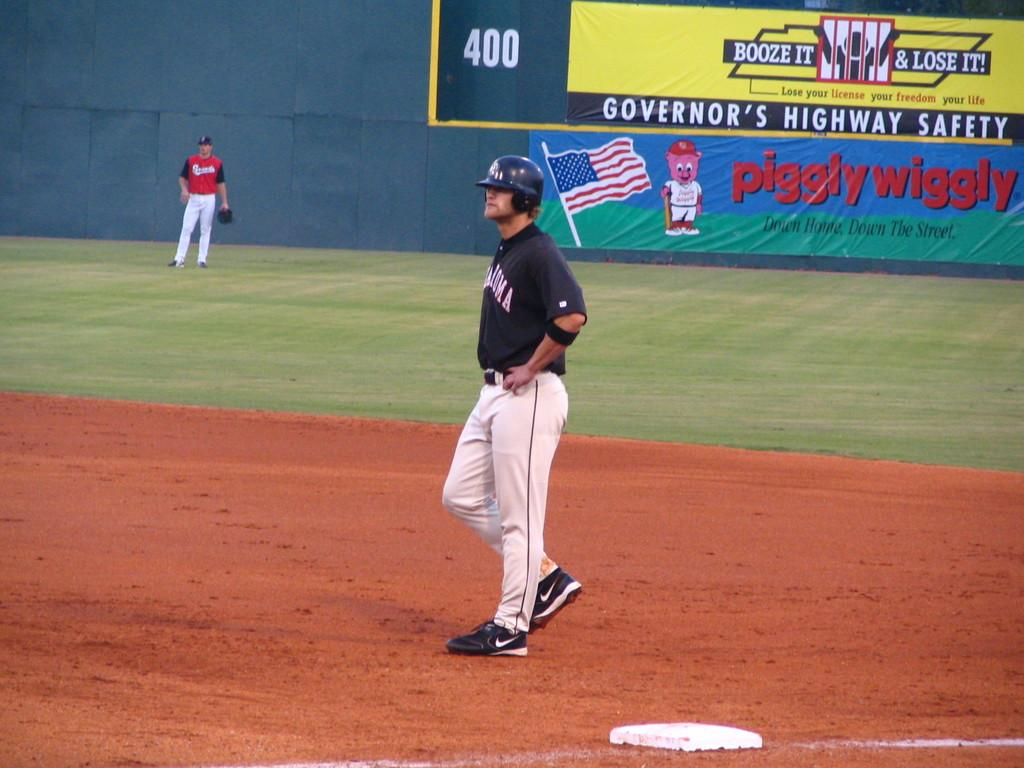Provide a one-sentence caption for the provided image. A baseball player is standing near first base with his hands on his hips in front of a piggly wiggly store advertising banner. 